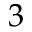<formula> <loc_0><loc_0><loc_500><loc_500>3</formula> 